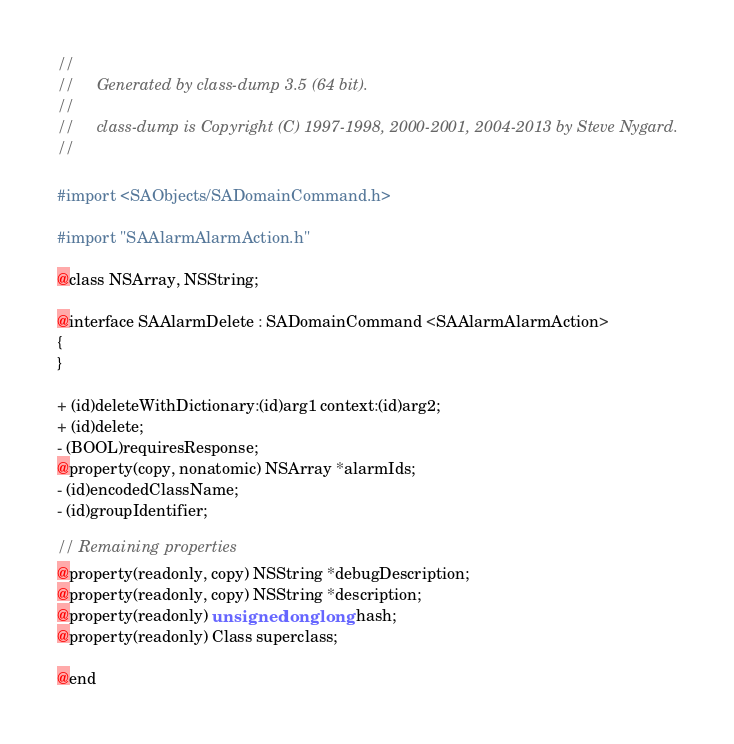Convert code to text. <code><loc_0><loc_0><loc_500><loc_500><_C_>//
//     Generated by class-dump 3.5 (64 bit).
//
//     class-dump is Copyright (C) 1997-1998, 2000-2001, 2004-2013 by Steve Nygard.
//

#import <SAObjects/SADomainCommand.h>

#import "SAAlarmAlarmAction.h"

@class NSArray, NSString;

@interface SAAlarmDelete : SADomainCommand <SAAlarmAlarmAction>
{
}

+ (id)deleteWithDictionary:(id)arg1 context:(id)arg2;
+ (id)delete;
- (BOOL)requiresResponse;
@property(copy, nonatomic) NSArray *alarmIds;
- (id)encodedClassName;
- (id)groupIdentifier;

// Remaining properties
@property(readonly, copy) NSString *debugDescription;
@property(readonly, copy) NSString *description;
@property(readonly) unsigned long long hash;
@property(readonly) Class superclass;

@end

</code> 